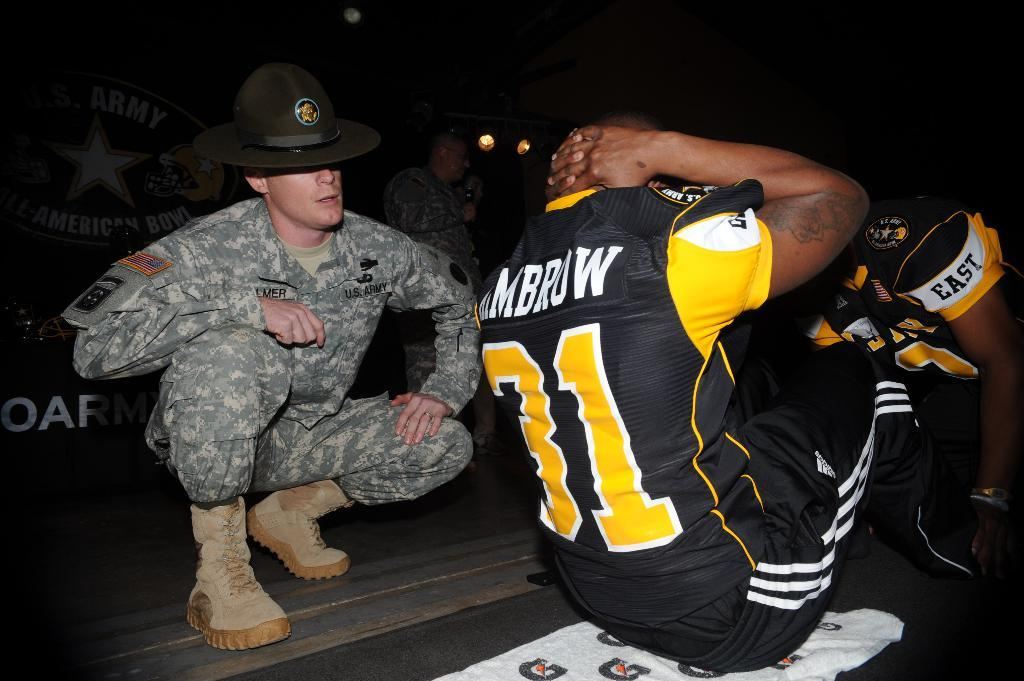<image>
Offer a succinct explanation of the picture presented. A drill sergeant monitors a player in a number 31 uniform during exercise. 